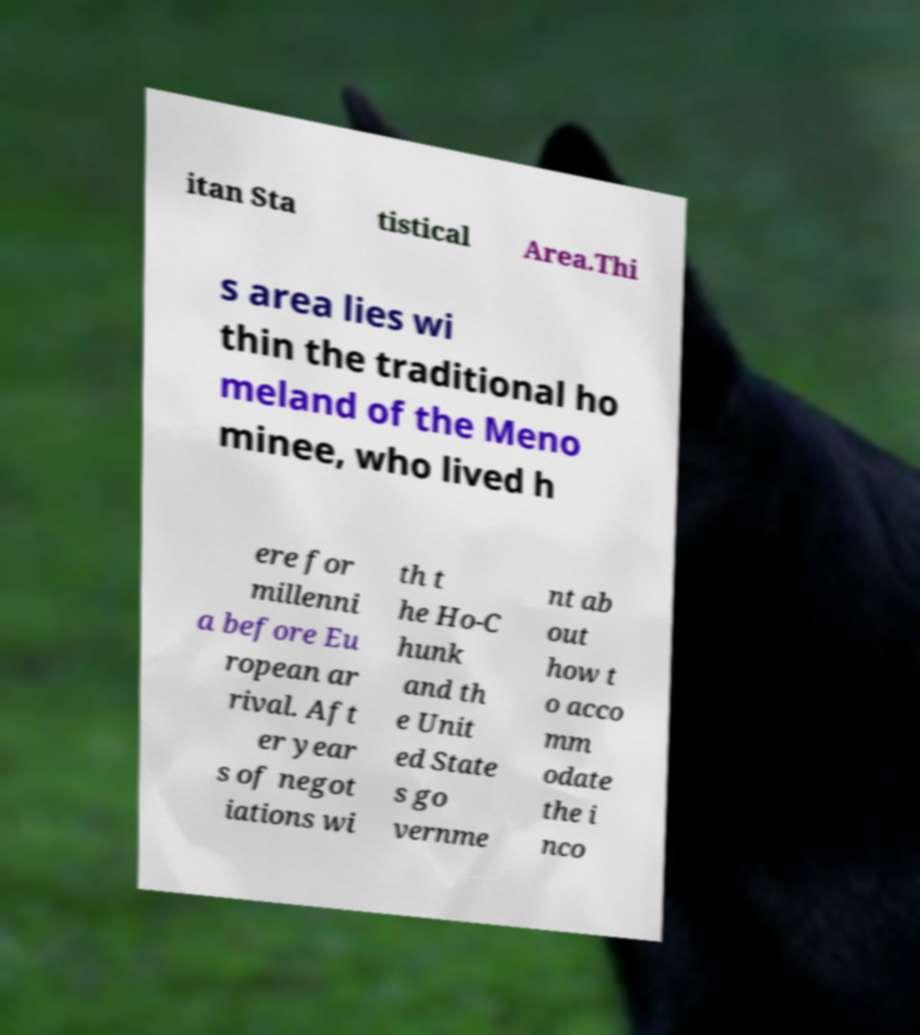Could you extract and type out the text from this image? itan Sta tistical Area.Thi s area lies wi thin the traditional ho meland of the Meno minee, who lived h ere for millenni a before Eu ropean ar rival. Aft er year s of negot iations wi th t he Ho-C hunk and th e Unit ed State s go vernme nt ab out how t o acco mm odate the i nco 